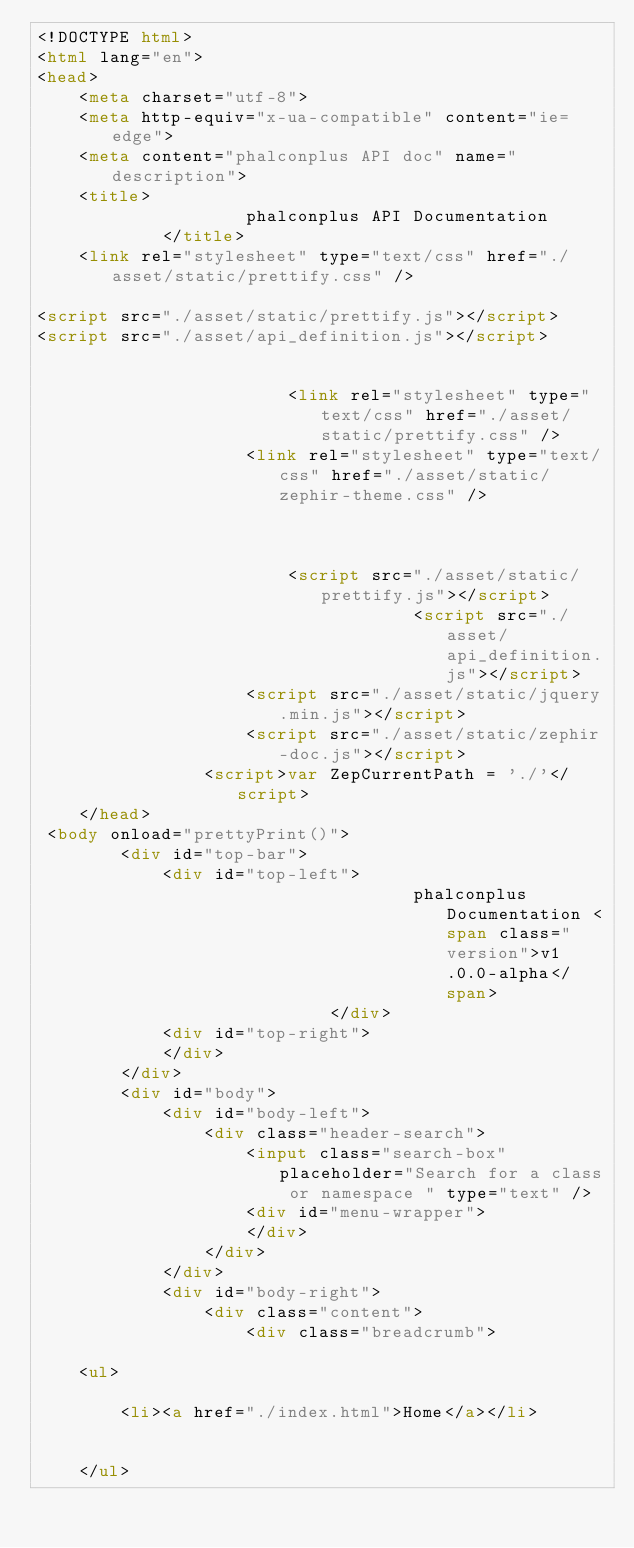Convert code to text. <code><loc_0><loc_0><loc_500><loc_500><_HTML_><!DOCTYPE html>
<html lang="en">
<head>
    <meta charset="utf-8">
    <meta http-equiv="x-ua-compatible" content="ie=edge">
    <meta content="phalconplus API doc" name="description">
    <title>
                    phalconplus API Documentation
            </title>
    <link rel="stylesheet" type="text/css" href="./asset/static/prettify.css" />

<script src="./asset/static/prettify.js"></script>
<script src="./asset/api_definition.js"></script>


                        <link rel="stylesheet" type="text/css" href="./asset/static/prettify.css" />
                    <link rel="stylesheet" type="text/css" href="./asset/static/zephir-theme.css" />
            
    

                        <script src="./asset/static/prettify.js"></script>
                                    <script src="./asset/api_definition.js"></script>
                    <script src="./asset/static/jquery.min.js"></script>
                    <script src="./asset/static/zephir-doc.js"></script>
                <script>var ZepCurrentPath = './'</script>
    </head>
 <body onload="prettyPrint()">
        <div id="top-bar">
            <div id="top-left">
                                    phalconplus Documentation <span class="version">v1.0.0-alpha</span>
                            </div>
            <div id="top-right">
            </div>
        </div>
        <div id="body">
            <div id="body-left">
                <div class="header-search">
                    <input class="search-box" placeholder="Search for a class or namespace " type="text" />
                    <div id="menu-wrapper">
                    </div>
                </div>
            </div>
            <div id="body-right">
                <div class="content">
                    <div class="breadcrumb">
    
    <ul>
        
        <li><a href="./index.html">Home</a></li>
        
                
    </ul>
    </code> 